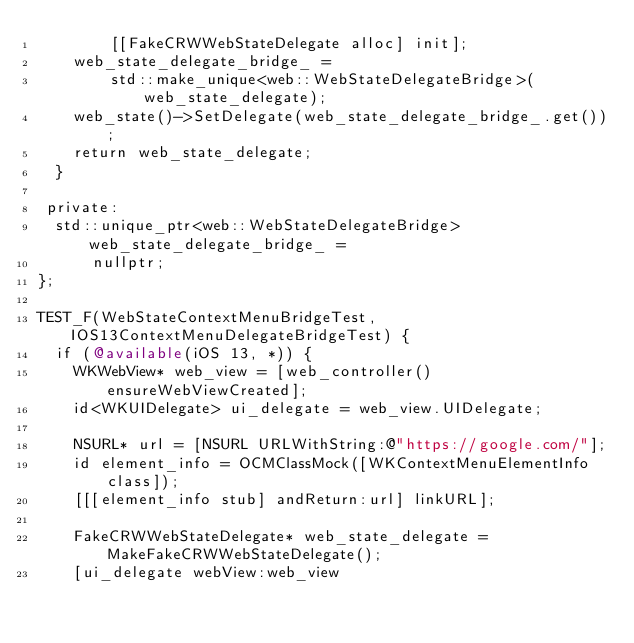Convert code to text. <code><loc_0><loc_0><loc_500><loc_500><_ObjectiveC_>        [[FakeCRWWebStateDelegate alloc] init];
    web_state_delegate_bridge_ =
        std::make_unique<web::WebStateDelegateBridge>(web_state_delegate);
    web_state()->SetDelegate(web_state_delegate_bridge_.get());
    return web_state_delegate;
  }

 private:
  std::unique_ptr<web::WebStateDelegateBridge> web_state_delegate_bridge_ =
      nullptr;
};

TEST_F(WebStateContextMenuBridgeTest, IOS13ContextMenuDelegateBridgeTest) {
  if (@available(iOS 13, *)) {
    WKWebView* web_view = [web_controller() ensureWebViewCreated];
    id<WKUIDelegate> ui_delegate = web_view.UIDelegate;

    NSURL* url = [NSURL URLWithString:@"https://google.com/"];
    id element_info = OCMClassMock([WKContextMenuElementInfo class]);
    [[[element_info stub] andReturn:url] linkURL];

    FakeCRWWebStateDelegate* web_state_delegate = MakeFakeCRWWebStateDelegate();
    [ui_delegate webView:web_view</code> 